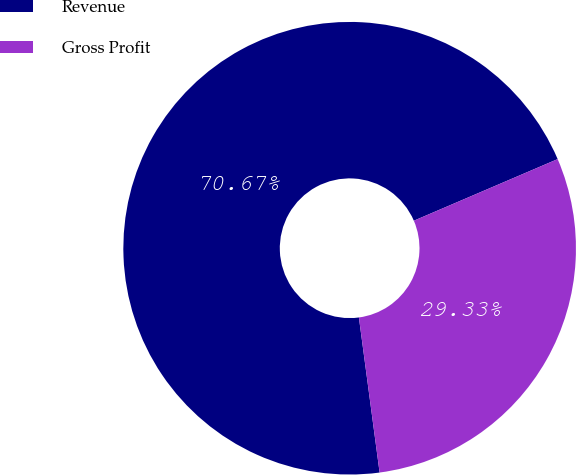<chart> <loc_0><loc_0><loc_500><loc_500><pie_chart><fcel>Revenue<fcel>Gross Profit<nl><fcel>70.67%<fcel>29.33%<nl></chart> 